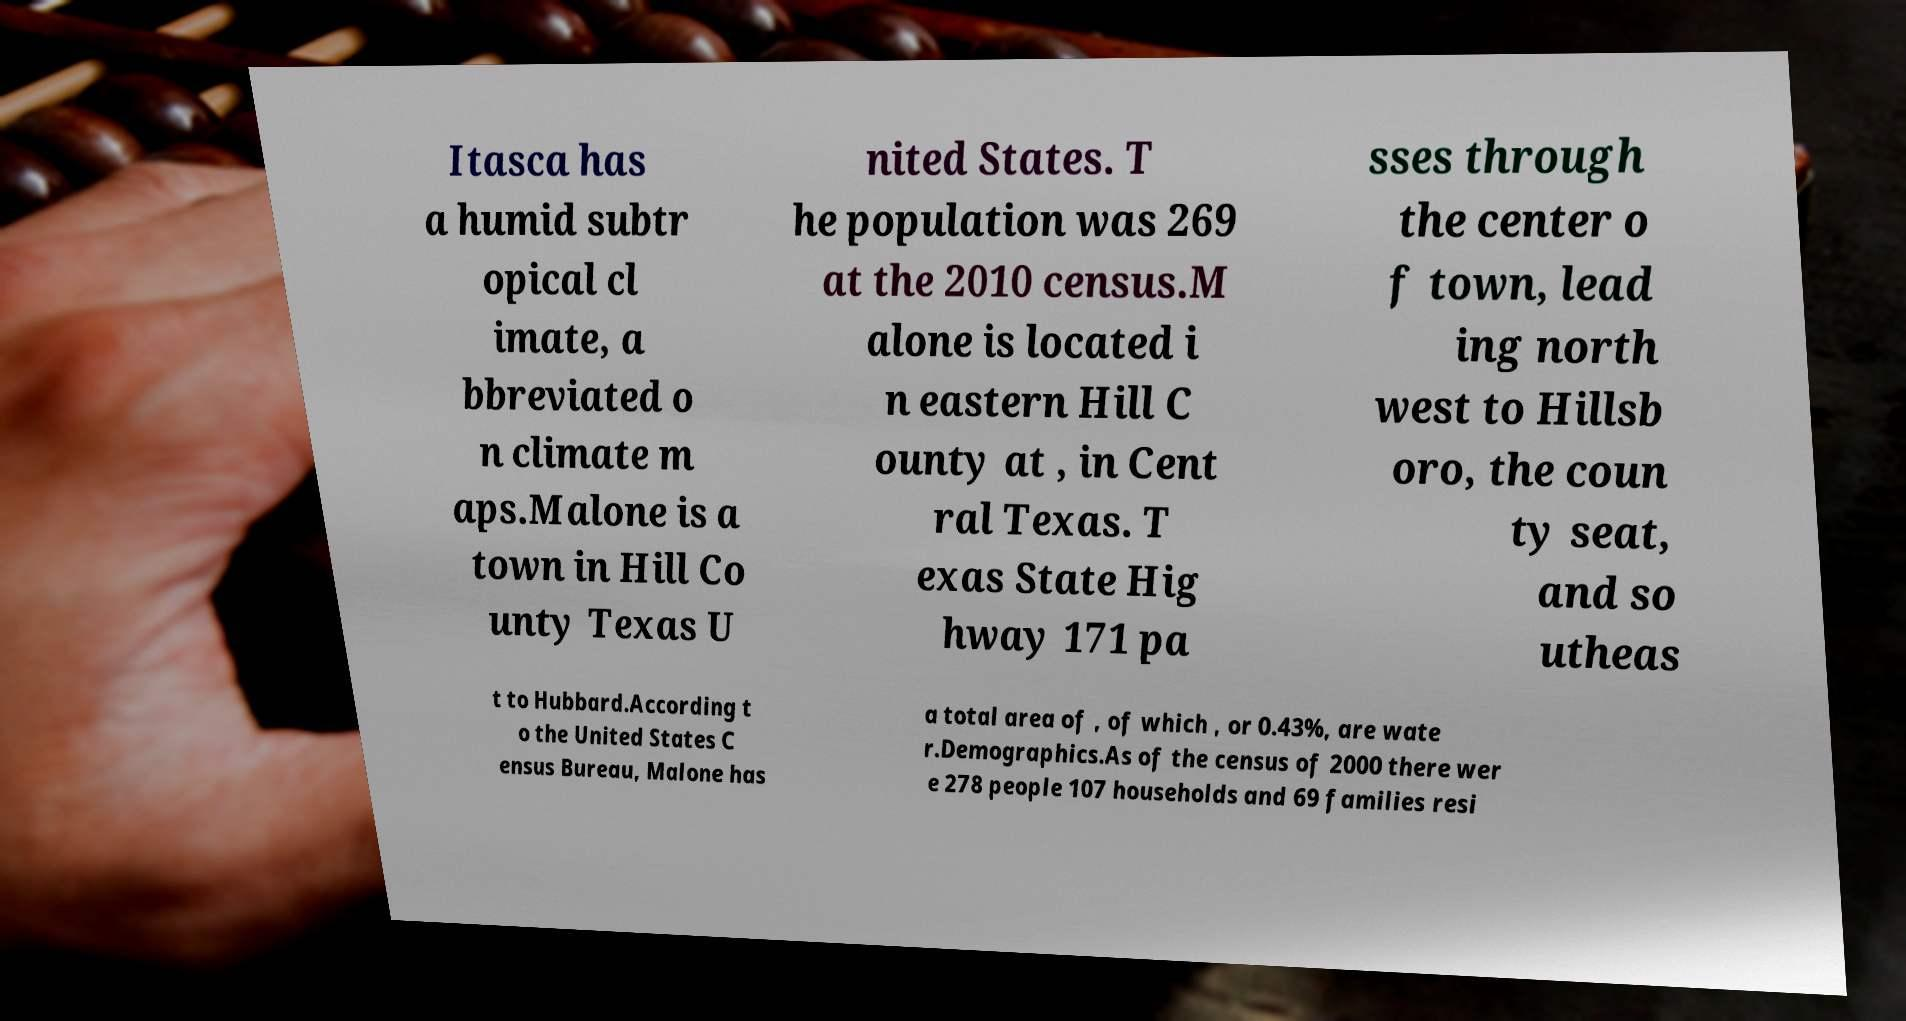Can you accurately transcribe the text from the provided image for me? Itasca has a humid subtr opical cl imate, a bbreviated o n climate m aps.Malone is a town in Hill Co unty Texas U nited States. T he population was 269 at the 2010 census.M alone is located i n eastern Hill C ounty at , in Cent ral Texas. T exas State Hig hway 171 pa sses through the center o f town, lead ing north west to Hillsb oro, the coun ty seat, and so utheas t to Hubbard.According t o the United States C ensus Bureau, Malone has a total area of , of which , or 0.43%, are wate r.Demographics.As of the census of 2000 there wer e 278 people 107 households and 69 families resi 